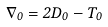Convert formula to latex. <formula><loc_0><loc_0><loc_500><loc_500>\nabla _ { 0 } = 2 D _ { 0 } - T _ { 0 }</formula> 